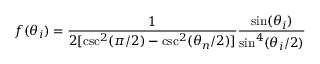<formula> <loc_0><loc_0><loc_500><loc_500>f ( \theta _ { i } ) = \frac { 1 } { 2 [ \csc ^ { 2 } ( \pi / 2 ) - \csc ^ { 2 } ( \theta _ { n } / 2 ) ] } \frac { \sin ( \theta _ { i } ) } { \sin ^ { 4 } ( \theta _ { i } / 2 ) }</formula> 